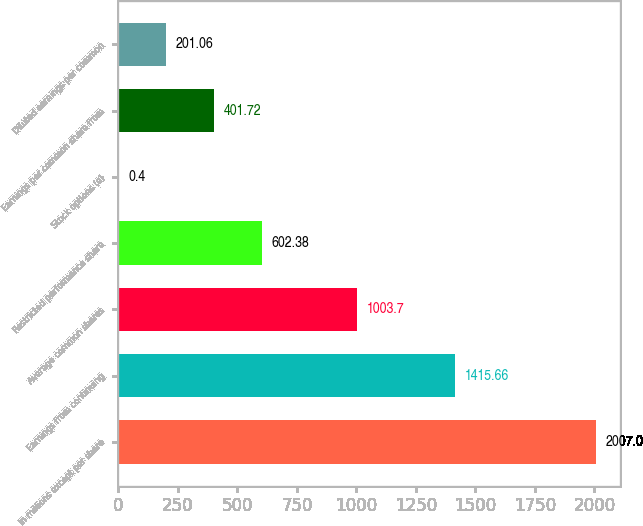Convert chart to OTSL. <chart><loc_0><loc_0><loc_500><loc_500><bar_chart><fcel>In millions except per share<fcel>Earnings from continuing<fcel>Average common shares<fcel>Restricted performance share<fcel>Stock options (a)<fcel>Earnings per common share from<fcel>Diluted earnings per common<nl><fcel>2007<fcel>1415.66<fcel>1003.7<fcel>602.38<fcel>0.4<fcel>401.72<fcel>201.06<nl></chart> 